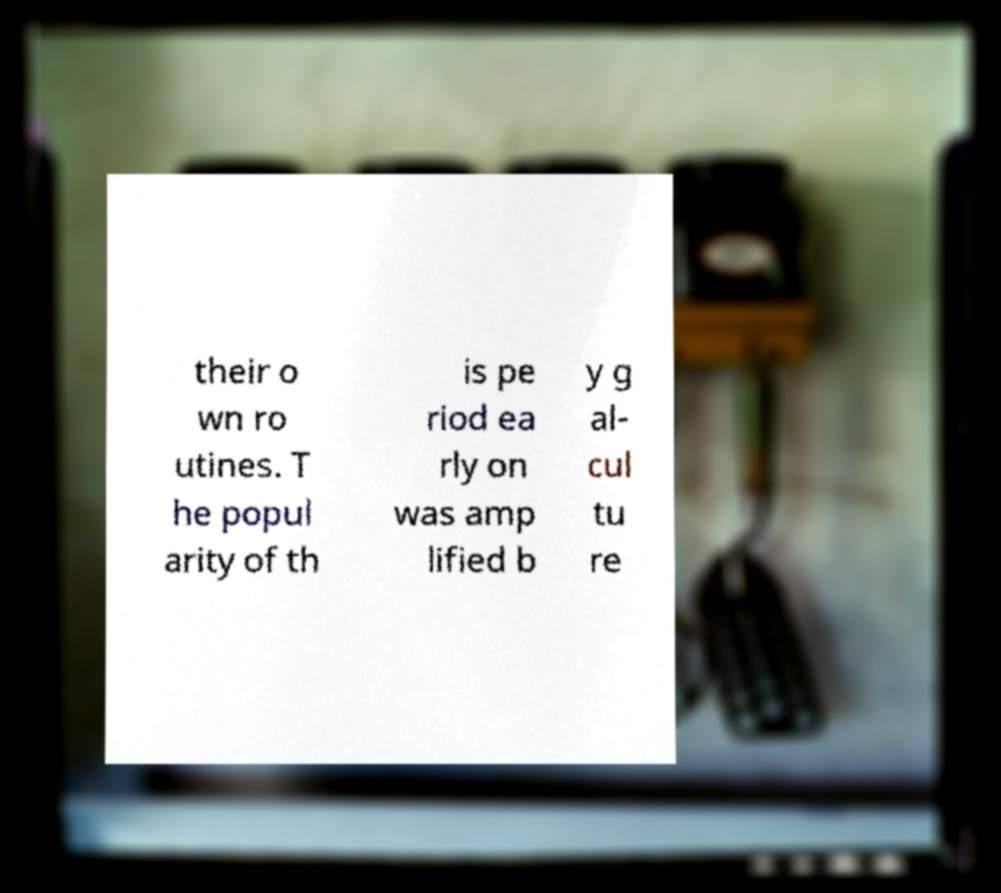What messages or text are displayed in this image? I need them in a readable, typed format. their o wn ro utines. T he popul arity of th is pe riod ea rly on was amp lified b y g al- cul tu re 